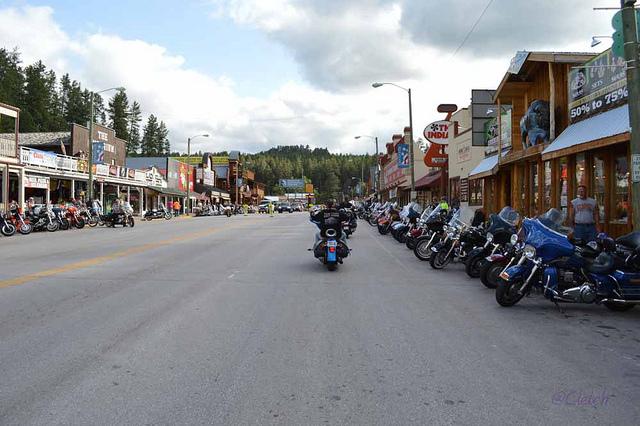What kind of people have gathered around here?
Give a very brief answer. Bikers. Urban or suburban?
Answer briefly. Suburban. Is there any parking left?
Answer briefly. Yes. What type of vehicle is parked here?
Write a very short answer. Motorcycle. Are all the motorcycles the same color?
Quick response, please. No. Is there a bike lane?
Write a very short answer. No. What job do all of the people on motorcycles have?
Keep it brief. Mechanic. What color is the last biker's shirt?
Be succinct. Black. 